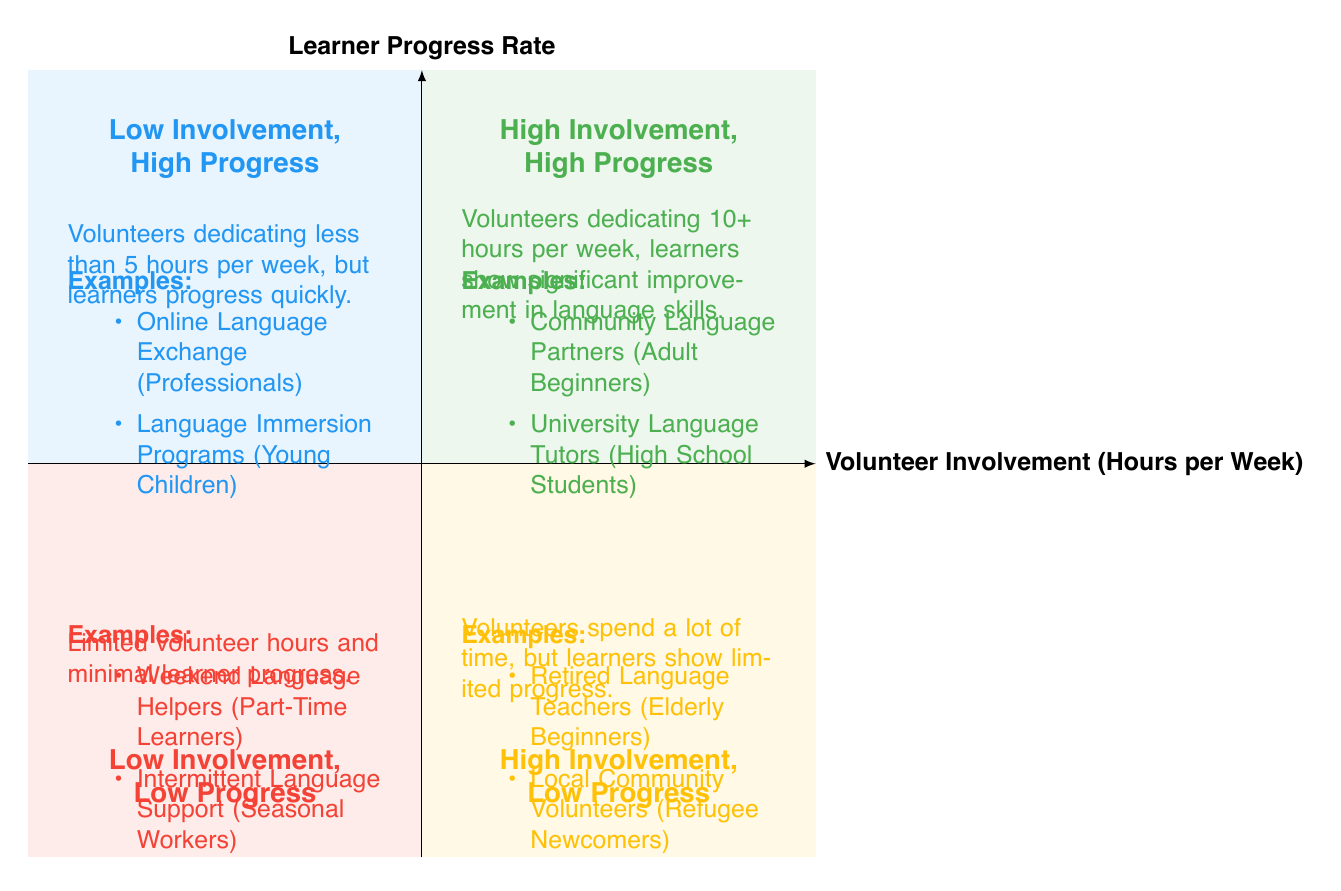What is the label of the quadrant with high involvement and high progress? The quadrant with high involvement and high progress is labeled as "High Involvement, High Progress" as indicated in the diagram.
Answer: High Involvement, High Progress How many examples are listed in the "Low Involvement, Low Progress" quadrant? The "Low Involvement, Low Progress" quadrant lists two examples: Weekend Language Helpers and Intermittent Language Support, as shown in the respective section of the diagram.
Answer: 2 What is the learner group mentioned in the "High Involvement, Low Progress" quadrant? The "High Involvement, Low Progress" quadrant includes the learner group "Elderly Beginners," which is specified along with its respective volunteer group in the diagram.
Answer: Elderly Beginners Based on the diagram, which quadrant shows a high involvement of volunteers but low progress in learners? The quadrant showing high involvement of volunteers while learners demonstrate low progress is "High Involvement, Low Progress," clearly indicated in the diagram.
Answer: High Involvement, Low Progress What do volunteers in the "Low Involvement, High Progress" quadrant typically spend? Volunteers in this quadrant dedicate less than 5 hours per week, which is explicitly stated in the characteristics for that quadrant in the diagram.
Answer: Less than 5 hours per week Which volunteer group is mentioned in the "High Involvement, High Progress" quadrant? The "High Involvement, High Progress" quadrant mentions the volunteer group "Community Language Partners," identified in the examples section of that quadrant.
Answer: Community Language Partners How does learner progress compare between the "Low Involvement, Low Progress" and "High Involvement, Low Progress" quadrants? Learner progress is minimal in both quadrants, but the "Low Involvement, Low Progress" quadrant indicates both limited volunteer time and minimal learner progress, while the "High Involvement, Low Progress" quadrant indicates high volunteer hours with limited progress.
Answer: Minimal learner progress in both What is a common characteristic of the "High Involvement, Low Progress" quadrant? A common characteristic of this quadrant includes volunteers spending a lot of time but achieving limited progress for the learners, as noted in the description of that section.
Answer: Volunteers spend a lot of time but achieve limited progress 